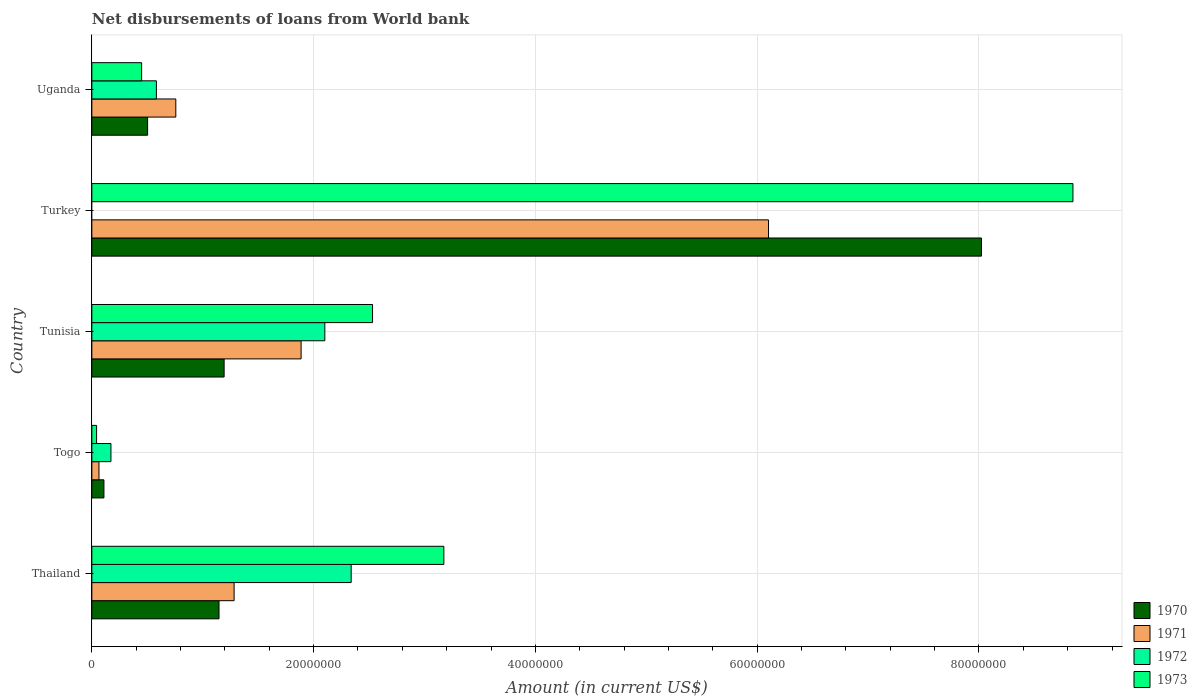How many different coloured bars are there?
Offer a terse response. 4. Are the number of bars per tick equal to the number of legend labels?
Provide a short and direct response. No. Are the number of bars on each tick of the Y-axis equal?
Keep it short and to the point. No. How many bars are there on the 3rd tick from the top?
Give a very brief answer. 4. How many bars are there on the 5th tick from the bottom?
Your answer should be compact. 4. What is the label of the 1st group of bars from the top?
Keep it short and to the point. Uganda. Across all countries, what is the maximum amount of loan disbursed from World Bank in 1973?
Provide a succinct answer. 8.85e+07. Across all countries, what is the minimum amount of loan disbursed from World Bank in 1970?
Your answer should be very brief. 1.09e+06. In which country was the amount of loan disbursed from World Bank in 1970 maximum?
Your response must be concise. Turkey. What is the total amount of loan disbursed from World Bank in 1972 in the graph?
Give a very brief answer. 5.19e+07. What is the difference between the amount of loan disbursed from World Bank in 1970 in Togo and that in Turkey?
Ensure brevity in your answer.  -7.91e+07. What is the difference between the amount of loan disbursed from World Bank in 1971 in Tunisia and the amount of loan disbursed from World Bank in 1972 in Turkey?
Keep it short and to the point. 1.89e+07. What is the average amount of loan disbursed from World Bank in 1971 per country?
Make the answer very short. 2.02e+07. What is the difference between the amount of loan disbursed from World Bank in 1971 and amount of loan disbursed from World Bank in 1973 in Turkey?
Keep it short and to the point. -2.75e+07. In how many countries, is the amount of loan disbursed from World Bank in 1970 greater than 64000000 US$?
Keep it short and to the point. 1. What is the ratio of the amount of loan disbursed from World Bank in 1972 in Thailand to that in Tunisia?
Your answer should be compact. 1.11. What is the difference between the highest and the second highest amount of loan disbursed from World Bank in 1972?
Give a very brief answer. 2.38e+06. What is the difference between the highest and the lowest amount of loan disbursed from World Bank in 1971?
Offer a very short reply. 6.04e+07. In how many countries, is the amount of loan disbursed from World Bank in 1970 greater than the average amount of loan disbursed from World Bank in 1970 taken over all countries?
Your answer should be very brief. 1. Is the sum of the amount of loan disbursed from World Bank in 1970 in Tunisia and Uganda greater than the maximum amount of loan disbursed from World Bank in 1972 across all countries?
Your answer should be compact. No. Is it the case that in every country, the sum of the amount of loan disbursed from World Bank in 1971 and amount of loan disbursed from World Bank in 1972 is greater than the sum of amount of loan disbursed from World Bank in 1970 and amount of loan disbursed from World Bank in 1973?
Provide a short and direct response. No. Is it the case that in every country, the sum of the amount of loan disbursed from World Bank in 1970 and amount of loan disbursed from World Bank in 1972 is greater than the amount of loan disbursed from World Bank in 1973?
Your answer should be compact. No. How many bars are there?
Offer a terse response. 19. How many countries are there in the graph?
Offer a terse response. 5. Does the graph contain any zero values?
Offer a very short reply. Yes. How many legend labels are there?
Offer a very short reply. 4. What is the title of the graph?
Ensure brevity in your answer.  Net disbursements of loans from World bank. Does "2012" appear as one of the legend labels in the graph?
Provide a succinct answer. No. What is the Amount (in current US$) in 1970 in Thailand?
Offer a very short reply. 1.15e+07. What is the Amount (in current US$) in 1971 in Thailand?
Your answer should be very brief. 1.28e+07. What is the Amount (in current US$) in 1972 in Thailand?
Provide a short and direct response. 2.34e+07. What is the Amount (in current US$) of 1973 in Thailand?
Ensure brevity in your answer.  3.17e+07. What is the Amount (in current US$) of 1970 in Togo?
Your answer should be compact. 1.09e+06. What is the Amount (in current US$) of 1971 in Togo?
Give a very brief answer. 6.42e+05. What is the Amount (in current US$) in 1972 in Togo?
Provide a short and direct response. 1.72e+06. What is the Amount (in current US$) in 1973 in Togo?
Ensure brevity in your answer.  4.29e+05. What is the Amount (in current US$) of 1970 in Tunisia?
Keep it short and to the point. 1.19e+07. What is the Amount (in current US$) of 1971 in Tunisia?
Keep it short and to the point. 1.89e+07. What is the Amount (in current US$) in 1972 in Tunisia?
Provide a succinct answer. 2.10e+07. What is the Amount (in current US$) in 1973 in Tunisia?
Keep it short and to the point. 2.53e+07. What is the Amount (in current US$) of 1970 in Turkey?
Your response must be concise. 8.02e+07. What is the Amount (in current US$) of 1971 in Turkey?
Ensure brevity in your answer.  6.10e+07. What is the Amount (in current US$) of 1972 in Turkey?
Provide a succinct answer. 0. What is the Amount (in current US$) of 1973 in Turkey?
Offer a terse response. 8.85e+07. What is the Amount (in current US$) in 1970 in Uganda?
Your answer should be very brief. 5.03e+06. What is the Amount (in current US$) of 1971 in Uganda?
Keep it short and to the point. 7.57e+06. What is the Amount (in current US$) in 1972 in Uganda?
Your answer should be compact. 5.82e+06. What is the Amount (in current US$) in 1973 in Uganda?
Ensure brevity in your answer.  4.49e+06. Across all countries, what is the maximum Amount (in current US$) in 1970?
Keep it short and to the point. 8.02e+07. Across all countries, what is the maximum Amount (in current US$) of 1971?
Give a very brief answer. 6.10e+07. Across all countries, what is the maximum Amount (in current US$) in 1972?
Make the answer very short. 2.34e+07. Across all countries, what is the maximum Amount (in current US$) in 1973?
Keep it short and to the point. 8.85e+07. Across all countries, what is the minimum Amount (in current US$) of 1970?
Make the answer very short. 1.09e+06. Across all countries, what is the minimum Amount (in current US$) in 1971?
Give a very brief answer. 6.42e+05. Across all countries, what is the minimum Amount (in current US$) of 1972?
Your response must be concise. 0. Across all countries, what is the minimum Amount (in current US$) of 1973?
Offer a terse response. 4.29e+05. What is the total Amount (in current US$) in 1970 in the graph?
Your answer should be very brief. 1.10e+08. What is the total Amount (in current US$) in 1971 in the graph?
Give a very brief answer. 1.01e+08. What is the total Amount (in current US$) of 1972 in the graph?
Ensure brevity in your answer.  5.19e+07. What is the total Amount (in current US$) of 1973 in the graph?
Your response must be concise. 1.50e+08. What is the difference between the Amount (in current US$) of 1970 in Thailand and that in Togo?
Your response must be concise. 1.04e+07. What is the difference between the Amount (in current US$) in 1971 in Thailand and that in Togo?
Make the answer very short. 1.22e+07. What is the difference between the Amount (in current US$) in 1972 in Thailand and that in Togo?
Your answer should be compact. 2.17e+07. What is the difference between the Amount (in current US$) of 1973 in Thailand and that in Togo?
Your answer should be very brief. 3.13e+07. What is the difference between the Amount (in current US$) of 1970 in Thailand and that in Tunisia?
Ensure brevity in your answer.  -4.60e+05. What is the difference between the Amount (in current US$) in 1971 in Thailand and that in Tunisia?
Provide a succinct answer. -6.04e+06. What is the difference between the Amount (in current US$) in 1972 in Thailand and that in Tunisia?
Provide a short and direct response. 2.38e+06. What is the difference between the Amount (in current US$) in 1973 in Thailand and that in Tunisia?
Provide a succinct answer. 6.43e+06. What is the difference between the Amount (in current US$) in 1970 in Thailand and that in Turkey?
Make the answer very short. -6.88e+07. What is the difference between the Amount (in current US$) of 1971 in Thailand and that in Turkey?
Provide a succinct answer. -4.82e+07. What is the difference between the Amount (in current US$) of 1973 in Thailand and that in Turkey?
Keep it short and to the point. -5.67e+07. What is the difference between the Amount (in current US$) of 1970 in Thailand and that in Uganda?
Keep it short and to the point. 6.44e+06. What is the difference between the Amount (in current US$) in 1971 in Thailand and that in Uganda?
Ensure brevity in your answer.  5.26e+06. What is the difference between the Amount (in current US$) of 1972 in Thailand and that in Uganda?
Offer a terse response. 1.76e+07. What is the difference between the Amount (in current US$) in 1973 in Thailand and that in Uganda?
Keep it short and to the point. 2.73e+07. What is the difference between the Amount (in current US$) in 1970 in Togo and that in Tunisia?
Keep it short and to the point. -1.08e+07. What is the difference between the Amount (in current US$) of 1971 in Togo and that in Tunisia?
Your answer should be compact. -1.82e+07. What is the difference between the Amount (in current US$) of 1972 in Togo and that in Tunisia?
Provide a short and direct response. -1.93e+07. What is the difference between the Amount (in current US$) in 1973 in Togo and that in Tunisia?
Ensure brevity in your answer.  -2.49e+07. What is the difference between the Amount (in current US$) in 1970 in Togo and that in Turkey?
Make the answer very short. -7.91e+07. What is the difference between the Amount (in current US$) of 1971 in Togo and that in Turkey?
Your answer should be very brief. -6.04e+07. What is the difference between the Amount (in current US$) in 1973 in Togo and that in Turkey?
Make the answer very short. -8.80e+07. What is the difference between the Amount (in current US$) of 1970 in Togo and that in Uganda?
Keep it short and to the point. -3.94e+06. What is the difference between the Amount (in current US$) in 1971 in Togo and that in Uganda?
Provide a succinct answer. -6.93e+06. What is the difference between the Amount (in current US$) of 1972 in Togo and that in Uganda?
Your answer should be compact. -4.10e+06. What is the difference between the Amount (in current US$) of 1973 in Togo and that in Uganda?
Keep it short and to the point. -4.06e+06. What is the difference between the Amount (in current US$) of 1970 in Tunisia and that in Turkey?
Your answer should be compact. -6.83e+07. What is the difference between the Amount (in current US$) in 1971 in Tunisia and that in Turkey?
Your response must be concise. -4.22e+07. What is the difference between the Amount (in current US$) in 1973 in Tunisia and that in Turkey?
Ensure brevity in your answer.  -6.32e+07. What is the difference between the Amount (in current US$) of 1970 in Tunisia and that in Uganda?
Give a very brief answer. 6.90e+06. What is the difference between the Amount (in current US$) in 1971 in Tunisia and that in Uganda?
Provide a short and direct response. 1.13e+07. What is the difference between the Amount (in current US$) of 1972 in Tunisia and that in Uganda?
Provide a short and direct response. 1.52e+07. What is the difference between the Amount (in current US$) in 1973 in Tunisia and that in Uganda?
Offer a terse response. 2.08e+07. What is the difference between the Amount (in current US$) of 1970 in Turkey and that in Uganda?
Your answer should be very brief. 7.52e+07. What is the difference between the Amount (in current US$) of 1971 in Turkey and that in Uganda?
Offer a terse response. 5.35e+07. What is the difference between the Amount (in current US$) of 1973 in Turkey and that in Uganda?
Offer a terse response. 8.40e+07. What is the difference between the Amount (in current US$) of 1970 in Thailand and the Amount (in current US$) of 1971 in Togo?
Offer a terse response. 1.08e+07. What is the difference between the Amount (in current US$) in 1970 in Thailand and the Amount (in current US$) in 1972 in Togo?
Offer a very short reply. 9.75e+06. What is the difference between the Amount (in current US$) of 1970 in Thailand and the Amount (in current US$) of 1973 in Togo?
Provide a short and direct response. 1.10e+07. What is the difference between the Amount (in current US$) in 1971 in Thailand and the Amount (in current US$) in 1972 in Togo?
Your answer should be very brief. 1.11e+07. What is the difference between the Amount (in current US$) in 1971 in Thailand and the Amount (in current US$) in 1973 in Togo?
Keep it short and to the point. 1.24e+07. What is the difference between the Amount (in current US$) in 1972 in Thailand and the Amount (in current US$) in 1973 in Togo?
Give a very brief answer. 2.30e+07. What is the difference between the Amount (in current US$) in 1970 in Thailand and the Amount (in current US$) in 1971 in Tunisia?
Your answer should be very brief. -7.40e+06. What is the difference between the Amount (in current US$) in 1970 in Thailand and the Amount (in current US$) in 1972 in Tunisia?
Provide a short and direct response. -9.54e+06. What is the difference between the Amount (in current US$) in 1970 in Thailand and the Amount (in current US$) in 1973 in Tunisia?
Ensure brevity in your answer.  -1.38e+07. What is the difference between the Amount (in current US$) of 1971 in Thailand and the Amount (in current US$) of 1972 in Tunisia?
Offer a terse response. -8.18e+06. What is the difference between the Amount (in current US$) of 1971 in Thailand and the Amount (in current US$) of 1973 in Tunisia?
Give a very brief answer. -1.25e+07. What is the difference between the Amount (in current US$) in 1972 in Thailand and the Amount (in current US$) in 1973 in Tunisia?
Your answer should be compact. -1.93e+06. What is the difference between the Amount (in current US$) of 1970 in Thailand and the Amount (in current US$) of 1971 in Turkey?
Offer a terse response. -4.96e+07. What is the difference between the Amount (in current US$) of 1970 in Thailand and the Amount (in current US$) of 1973 in Turkey?
Your answer should be compact. -7.70e+07. What is the difference between the Amount (in current US$) in 1971 in Thailand and the Amount (in current US$) in 1973 in Turkey?
Provide a short and direct response. -7.56e+07. What is the difference between the Amount (in current US$) of 1972 in Thailand and the Amount (in current US$) of 1973 in Turkey?
Offer a very short reply. -6.51e+07. What is the difference between the Amount (in current US$) of 1970 in Thailand and the Amount (in current US$) of 1971 in Uganda?
Provide a succinct answer. 3.90e+06. What is the difference between the Amount (in current US$) in 1970 in Thailand and the Amount (in current US$) in 1972 in Uganda?
Offer a terse response. 5.65e+06. What is the difference between the Amount (in current US$) in 1970 in Thailand and the Amount (in current US$) in 1973 in Uganda?
Keep it short and to the point. 6.98e+06. What is the difference between the Amount (in current US$) in 1971 in Thailand and the Amount (in current US$) in 1972 in Uganda?
Give a very brief answer. 7.01e+06. What is the difference between the Amount (in current US$) of 1971 in Thailand and the Amount (in current US$) of 1973 in Uganda?
Ensure brevity in your answer.  8.34e+06. What is the difference between the Amount (in current US$) of 1972 in Thailand and the Amount (in current US$) of 1973 in Uganda?
Give a very brief answer. 1.89e+07. What is the difference between the Amount (in current US$) of 1970 in Togo and the Amount (in current US$) of 1971 in Tunisia?
Offer a very short reply. -1.78e+07. What is the difference between the Amount (in current US$) of 1970 in Togo and the Amount (in current US$) of 1972 in Tunisia?
Ensure brevity in your answer.  -1.99e+07. What is the difference between the Amount (in current US$) in 1970 in Togo and the Amount (in current US$) in 1973 in Tunisia?
Your answer should be compact. -2.42e+07. What is the difference between the Amount (in current US$) in 1971 in Togo and the Amount (in current US$) in 1972 in Tunisia?
Provide a short and direct response. -2.04e+07. What is the difference between the Amount (in current US$) of 1971 in Togo and the Amount (in current US$) of 1973 in Tunisia?
Make the answer very short. -2.47e+07. What is the difference between the Amount (in current US$) in 1972 in Togo and the Amount (in current US$) in 1973 in Tunisia?
Provide a succinct answer. -2.36e+07. What is the difference between the Amount (in current US$) of 1970 in Togo and the Amount (in current US$) of 1971 in Turkey?
Your response must be concise. -5.99e+07. What is the difference between the Amount (in current US$) in 1970 in Togo and the Amount (in current US$) in 1973 in Turkey?
Keep it short and to the point. -8.74e+07. What is the difference between the Amount (in current US$) in 1971 in Togo and the Amount (in current US$) in 1973 in Turkey?
Provide a short and direct response. -8.78e+07. What is the difference between the Amount (in current US$) of 1972 in Togo and the Amount (in current US$) of 1973 in Turkey?
Provide a short and direct response. -8.68e+07. What is the difference between the Amount (in current US$) of 1970 in Togo and the Amount (in current US$) of 1971 in Uganda?
Keep it short and to the point. -6.48e+06. What is the difference between the Amount (in current US$) of 1970 in Togo and the Amount (in current US$) of 1972 in Uganda?
Keep it short and to the point. -4.73e+06. What is the difference between the Amount (in current US$) of 1970 in Togo and the Amount (in current US$) of 1973 in Uganda?
Provide a short and direct response. -3.40e+06. What is the difference between the Amount (in current US$) in 1971 in Togo and the Amount (in current US$) in 1972 in Uganda?
Keep it short and to the point. -5.18e+06. What is the difference between the Amount (in current US$) in 1971 in Togo and the Amount (in current US$) in 1973 in Uganda?
Ensure brevity in your answer.  -3.85e+06. What is the difference between the Amount (in current US$) of 1972 in Togo and the Amount (in current US$) of 1973 in Uganda?
Ensure brevity in your answer.  -2.77e+06. What is the difference between the Amount (in current US$) of 1970 in Tunisia and the Amount (in current US$) of 1971 in Turkey?
Your answer should be compact. -4.91e+07. What is the difference between the Amount (in current US$) in 1970 in Tunisia and the Amount (in current US$) in 1973 in Turkey?
Ensure brevity in your answer.  -7.65e+07. What is the difference between the Amount (in current US$) of 1971 in Tunisia and the Amount (in current US$) of 1973 in Turkey?
Keep it short and to the point. -6.96e+07. What is the difference between the Amount (in current US$) of 1972 in Tunisia and the Amount (in current US$) of 1973 in Turkey?
Provide a short and direct response. -6.75e+07. What is the difference between the Amount (in current US$) in 1970 in Tunisia and the Amount (in current US$) in 1971 in Uganda?
Your response must be concise. 4.36e+06. What is the difference between the Amount (in current US$) of 1970 in Tunisia and the Amount (in current US$) of 1972 in Uganda?
Keep it short and to the point. 6.11e+06. What is the difference between the Amount (in current US$) of 1970 in Tunisia and the Amount (in current US$) of 1973 in Uganda?
Ensure brevity in your answer.  7.44e+06. What is the difference between the Amount (in current US$) in 1971 in Tunisia and the Amount (in current US$) in 1972 in Uganda?
Provide a succinct answer. 1.30e+07. What is the difference between the Amount (in current US$) of 1971 in Tunisia and the Amount (in current US$) of 1973 in Uganda?
Offer a very short reply. 1.44e+07. What is the difference between the Amount (in current US$) in 1972 in Tunisia and the Amount (in current US$) in 1973 in Uganda?
Provide a short and direct response. 1.65e+07. What is the difference between the Amount (in current US$) in 1970 in Turkey and the Amount (in current US$) in 1971 in Uganda?
Your answer should be very brief. 7.27e+07. What is the difference between the Amount (in current US$) of 1970 in Turkey and the Amount (in current US$) of 1972 in Uganda?
Give a very brief answer. 7.44e+07. What is the difference between the Amount (in current US$) of 1970 in Turkey and the Amount (in current US$) of 1973 in Uganda?
Give a very brief answer. 7.57e+07. What is the difference between the Amount (in current US$) of 1971 in Turkey and the Amount (in current US$) of 1972 in Uganda?
Your answer should be compact. 5.52e+07. What is the difference between the Amount (in current US$) in 1971 in Turkey and the Amount (in current US$) in 1973 in Uganda?
Your answer should be very brief. 5.65e+07. What is the average Amount (in current US$) of 1970 per country?
Make the answer very short. 2.19e+07. What is the average Amount (in current US$) of 1971 per country?
Offer a terse response. 2.02e+07. What is the average Amount (in current US$) of 1972 per country?
Ensure brevity in your answer.  1.04e+07. What is the average Amount (in current US$) of 1973 per country?
Your answer should be very brief. 3.01e+07. What is the difference between the Amount (in current US$) of 1970 and Amount (in current US$) of 1971 in Thailand?
Provide a short and direct response. -1.36e+06. What is the difference between the Amount (in current US$) of 1970 and Amount (in current US$) of 1972 in Thailand?
Keep it short and to the point. -1.19e+07. What is the difference between the Amount (in current US$) of 1970 and Amount (in current US$) of 1973 in Thailand?
Your answer should be very brief. -2.03e+07. What is the difference between the Amount (in current US$) in 1971 and Amount (in current US$) in 1972 in Thailand?
Provide a succinct answer. -1.06e+07. What is the difference between the Amount (in current US$) in 1971 and Amount (in current US$) in 1973 in Thailand?
Make the answer very short. -1.89e+07. What is the difference between the Amount (in current US$) of 1972 and Amount (in current US$) of 1973 in Thailand?
Give a very brief answer. -8.36e+06. What is the difference between the Amount (in current US$) of 1970 and Amount (in current US$) of 1971 in Togo?
Give a very brief answer. 4.49e+05. What is the difference between the Amount (in current US$) in 1970 and Amount (in current US$) in 1972 in Togo?
Your response must be concise. -6.31e+05. What is the difference between the Amount (in current US$) of 1970 and Amount (in current US$) of 1973 in Togo?
Keep it short and to the point. 6.62e+05. What is the difference between the Amount (in current US$) in 1971 and Amount (in current US$) in 1972 in Togo?
Make the answer very short. -1.08e+06. What is the difference between the Amount (in current US$) in 1971 and Amount (in current US$) in 1973 in Togo?
Provide a short and direct response. 2.13e+05. What is the difference between the Amount (in current US$) in 1972 and Amount (in current US$) in 1973 in Togo?
Provide a succinct answer. 1.29e+06. What is the difference between the Amount (in current US$) in 1970 and Amount (in current US$) in 1971 in Tunisia?
Your answer should be compact. -6.94e+06. What is the difference between the Amount (in current US$) of 1970 and Amount (in current US$) of 1972 in Tunisia?
Your response must be concise. -9.08e+06. What is the difference between the Amount (in current US$) in 1970 and Amount (in current US$) in 1973 in Tunisia?
Give a very brief answer. -1.34e+07. What is the difference between the Amount (in current US$) in 1971 and Amount (in current US$) in 1972 in Tunisia?
Provide a short and direct response. -2.14e+06. What is the difference between the Amount (in current US$) in 1971 and Amount (in current US$) in 1973 in Tunisia?
Your answer should be very brief. -6.44e+06. What is the difference between the Amount (in current US$) in 1972 and Amount (in current US$) in 1973 in Tunisia?
Offer a very short reply. -4.30e+06. What is the difference between the Amount (in current US$) in 1970 and Amount (in current US$) in 1971 in Turkey?
Offer a very short reply. 1.92e+07. What is the difference between the Amount (in current US$) in 1970 and Amount (in current US$) in 1973 in Turkey?
Your response must be concise. -8.25e+06. What is the difference between the Amount (in current US$) of 1971 and Amount (in current US$) of 1973 in Turkey?
Your answer should be compact. -2.75e+07. What is the difference between the Amount (in current US$) of 1970 and Amount (in current US$) of 1971 in Uganda?
Provide a succinct answer. -2.54e+06. What is the difference between the Amount (in current US$) of 1970 and Amount (in current US$) of 1972 in Uganda?
Offer a terse response. -7.94e+05. What is the difference between the Amount (in current US$) of 1970 and Amount (in current US$) of 1973 in Uganda?
Your response must be concise. 5.40e+05. What is the difference between the Amount (in current US$) in 1971 and Amount (in current US$) in 1972 in Uganda?
Give a very brief answer. 1.75e+06. What is the difference between the Amount (in current US$) in 1971 and Amount (in current US$) in 1973 in Uganda?
Make the answer very short. 3.08e+06. What is the difference between the Amount (in current US$) in 1972 and Amount (in current US$) in 1973 in Uganda?
Provide a short and direct response. 1.33e+06. What is the ratio of the Amount (in current US$) of 1970 in Thailand to that in Togo?
Offer a very short reply. 10.51. What is the ratio of the Amount (in current US$) of 1971 in Thailand to that in Togo?
Offer a terse response. 19.98. What is the ratio of the Amount (in current US$) in 1972 in Thailand to that in Togo?
Ensure brevity in your answer.  13.58. What is the ratio of the Amount (in current US$) of 1973 in Thailand to that in Togo?
Your answer should be very brief. 74. What is the ratio of the Amount (in current US$) of 1970 in Thailand to that in Tunisia?
Offer a terse response. 0.96. What is the ratio of the Amount (in current US$) in 1971 in Thailand to that in Tunisia?
Ensure brevity in your answer.  0.68. What is the ratio of the Amount (in current US$) in 1972 in Thailand to that in Tunisia?
Give a very brief answer. 1.11. What is the ratio of the Amount (in current US$) of 1973 in Thailand to that in Tunisia?
Offer a very short reply. 1.25. What is the ratio of the Amount (in current US$) in 1970 in Thailand to that in Turkey?
Ensure brevity in your answer.  0.14. What is the ratio of the Amount (in current US$) in 1971 in Thailand to that in Turkey?
Make the answer very short. 0.21. What is the ratio of the Amount (in current US$) of 1973 in Thailand to that in Turkey?
Provide a succinct answer. 0.36. What is the ratio of the Amount (in current US$) in 1970 in Thailand to that in Uganda?
Keep it short and to the point. 2.28. What is the ratio of the Amount (in current US$) in 1971 in Thailand to that in Uganda?
Your response must be concise. 1.69. What is the ratio of the Amount (in current US$) in 1972 in Thailand to that in Uganda?
Keep it short and to the point. 4.02. What is the ratio of the Amount (in current US$) in 1973 in Thailand to that in Uganda?
Your answer should be very brief. 7.07. What is the ratio of the Amount (in current US$) in 1970 in Togo to that in Tunisia?
Your answer should be compact. 0.09. What is the ratio of the Amount (in current US$) in 1971 in Togo to that in Tunisia?
Ensure brevity in your answer.  0.03. What is the ratio of the Amount (in current US$) of 1972 in Togo to that in Tunisia?
Ensure brevity in your answer.  0.08. What is the ratio of the Amount (in current US$) of 1973 in Togo to that in Tunisia?
Your answer should be compact. 0.02. What is the ratio of the Amount (in current US$) in 1970 in Togo to that in Turkey?
Offer a very short reply. 0.01. What is the ratio of the Amount (in current US$) in 1971 in Togo to that in Turkey?
Ensure brevity in your answer.  0.01. What is the ratio of the Amount (in current US$) in 1973 in Togo to that in Turkey?
Your answer should be very brief. 0. What is the ratio of the Amount (in current US$) in 1970 in Togo to that in Uganda?
Make the answer very short. 0.22. What is the ratio of the Amount (in current US$) in 1971 in Togo to that in Uganda?
Your answer should be very brief. 0.08. What is the ratio of the Amount (in current US$) in 1972 in Togo to that in Uganda?
Ensure brevity in your answer.  0.3. What is the ratio of the Amount (in current US$) in 1973 in Togo to that in Uganda?
Provide a succinct answer. 0.1. What is the ratio of the Amount (in current US$) in 1970 in Tunisia to that in Turkey?
Your answer should be very brief. 0.15. What is the ratio of the Amount (in current US$) in 1971 in Tunisia to that in Turkey?
Make the answer very short. 0.31. What is the ratio of the Amount (in current US$) in 1973 in Tunisia to that in Turkey?
Offer a terse response. 0.29. What is the ratio of the Amount (in current US$) of 1970 in Tunisia to that in Uganda?
Your answer should be very brief. 2.37. What is the ratio of the Amount (in current US$) of 1971 in Tunisia to that in Uganda?
Offer a very short reply. 2.49. What is the ratio of the Amount (in current US$) of 1972 in Tunisia to that in Uganda?
Provide a short and direct response. 3.61. What is the ratio of the Amount (in current US$) in 1973 in Tunisia to that in Uganda?
Provide a short and direct response. 5.64. What is the ratio of the Amount (in current US$) of 1970 in Turkey to that in Uganda?
Your answer should be very brief. 15.95. What is the ratio of the Amount (in current US$) in 1971 in Turkey to that in Uganda?
Your response must be concise. 8.06. What is the ratio of the Amount (in current US$) of 1973 in Turkey to that in Uganda?
Provide a short and direct response. 19.71. What is the difference between the highest and the second highest Amount (in current US$) of 1970?
Your response must be concise. 6.83e+07. What is the difference between the highest and the second highest Amount (in current US$) of 1971?
Offer a very short reply. 4.22e+07. What is the difference between the highest and the second highest Amount (in current US$) of 1972?
Provide a short and direct response. 2.38e+06. What is the difference between the highest and the second highest Amount (in current US$) in 1973?
Your response must be concise. 5.67e+07. What is the difference between the highest and the lowest Amount (in current US$) in 1970?
Offer a terse response. 7.91e+07. What is the difference between the highest and the lowest Amount (in current US$) of 1971?
Keep it short and to the point. 6.04e+07. What is the difference between the highest and the lowest Amount (in current US$) in 1972?
Offer a very short reply. 2.34e+07. What is the difference between the highest and the lowest Amount (in current US$) in 1973?
Your answer should be very brief. 8.80e+07. 